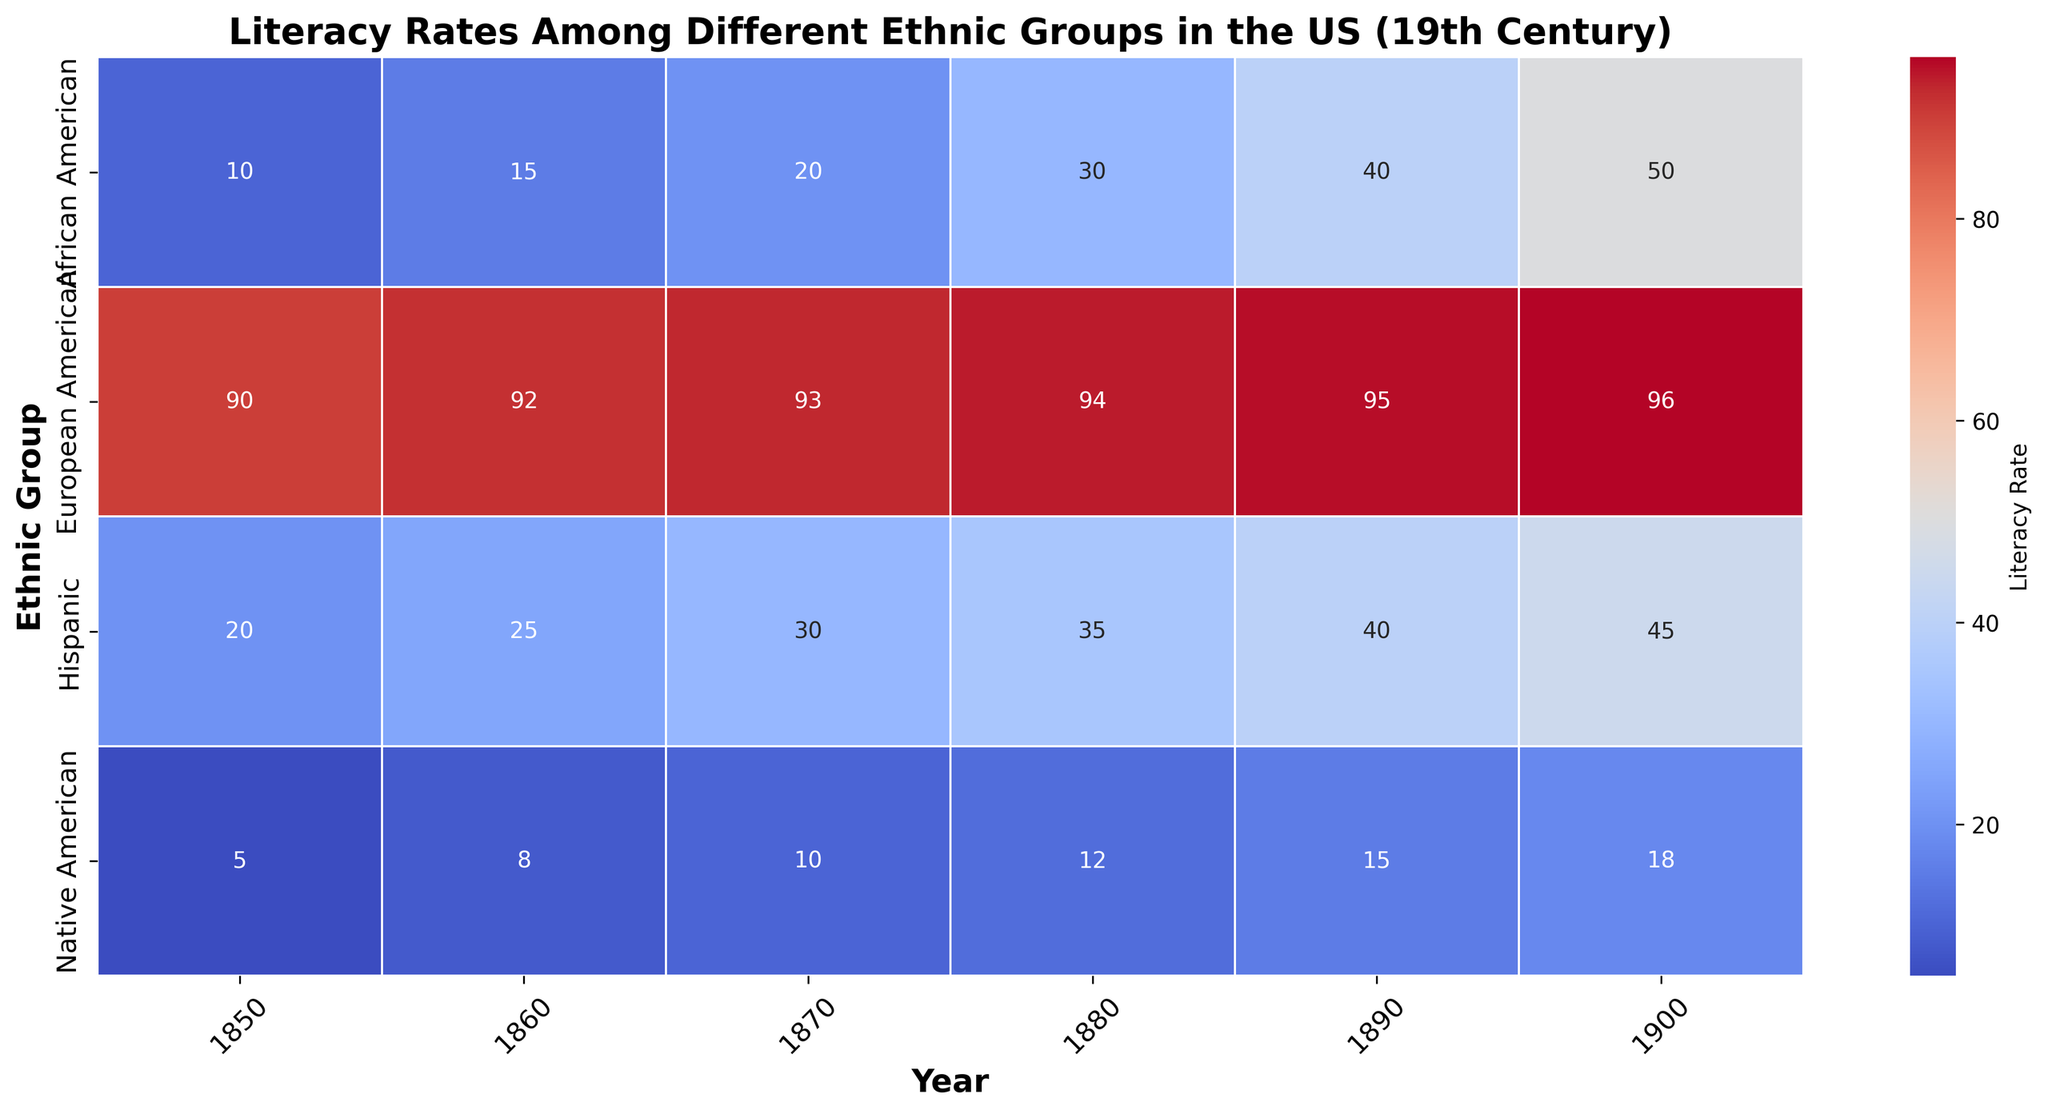What is the average literacy rate of African Americans throughout the years shown? To find the average literacy rate of African Americans, sum the literacy rates for each year and then divide by the number of years. The rates are 10, 15, 20, 30, 40, 50. Summing these values gives 165. There are 6 years, so the average is 165/6 = 27.5.
Answer: 27.5 How does the literacy rate of Native Americans in 1900 compare to their rate in 1850? The literacy rate for Native Americans in 1850 is 5, while in 1900 it is 18. The comparison shows that the literacy rate in 1900 is higher than in 1850.
Answer: Higher Which ethnic group shows the greatest increase in literacy rate from 1850 to 1900? To determine the greatest increase, subtract the literacy rate in 1850 from the rate in 1900 for each ethnic group. African Americans increase by 40 (50-10), European Americans by 6 (96-90), Native Americans by 13 (18-5), and Hispanics by 25 (45-20). The greatest increase is for African Americans.
Answer: African Americans What is the total literacy rate for all ethnic groups in 1880? Sum the literacy rates for each ethnic group in 1880: 30 (African American) + 94 (European American) + 12 (Native American) + 35 (Hispanic). The total is 171.
Answer: 171 Which ethnic group had the highest literacy rate in 1860? In 1860, the literacy rates are as follows: African American (15), European American (92), Native American (8), Hispanic (25). The highest rate is for European Americans.
Answer: European Americans Is there any year where Hispanic literacy rates surpass Native American rates? Comparing Hispanic and Native American literacy rates across the years: Hispanic rates are higher in every year (1850: 20 vs 5, 1860: 25 vs 8, 1870: 30 vs 10, 1880: 35 vs 12, 1890: 40 vs 15, 1900: 45 vs 18).
Answer: Yes What is the difference in literacy rate between European Americans and African Americans in 1890? The literacy rate for European Americans in 1890 is 95, and for African Americans, it is 40. The difference is 95 - 40 = 55.
Answer: 55 How does the pattern of change in literacy rates over time compare between African Americans and Hispanics? African Americans’ literacy rates show a steady increase from 10 to 50 (an increase of 40). Hispanics’ rates also increase steadily from 20 to 45 (an increase of 25). Both groups show an upward trend, but African Americans exhibit a larger increase.
Answer: African Americans show a larger increase What was the average literacy rate across all ethnic groups in 1850? Sum the literacy rates across all ethnic groups in 1850 and divide by the number of groups. The rates are 10, 90, 5, 20; summing these gives 125. There are 4 groups, so the average is 125/4 = 31.25.
Answer: 31.25 Which two ethnic groups have the smallest difference in literacy rates in 1900, and what is the difference? In 1900, the literacy rates are: African American (50), European American (96), Native American (18), Hispanic (45). The smallest difference is between African Americans and Hispanics: 50 - 45 = 5.
Answer: African Americans and Hispanics, 5 